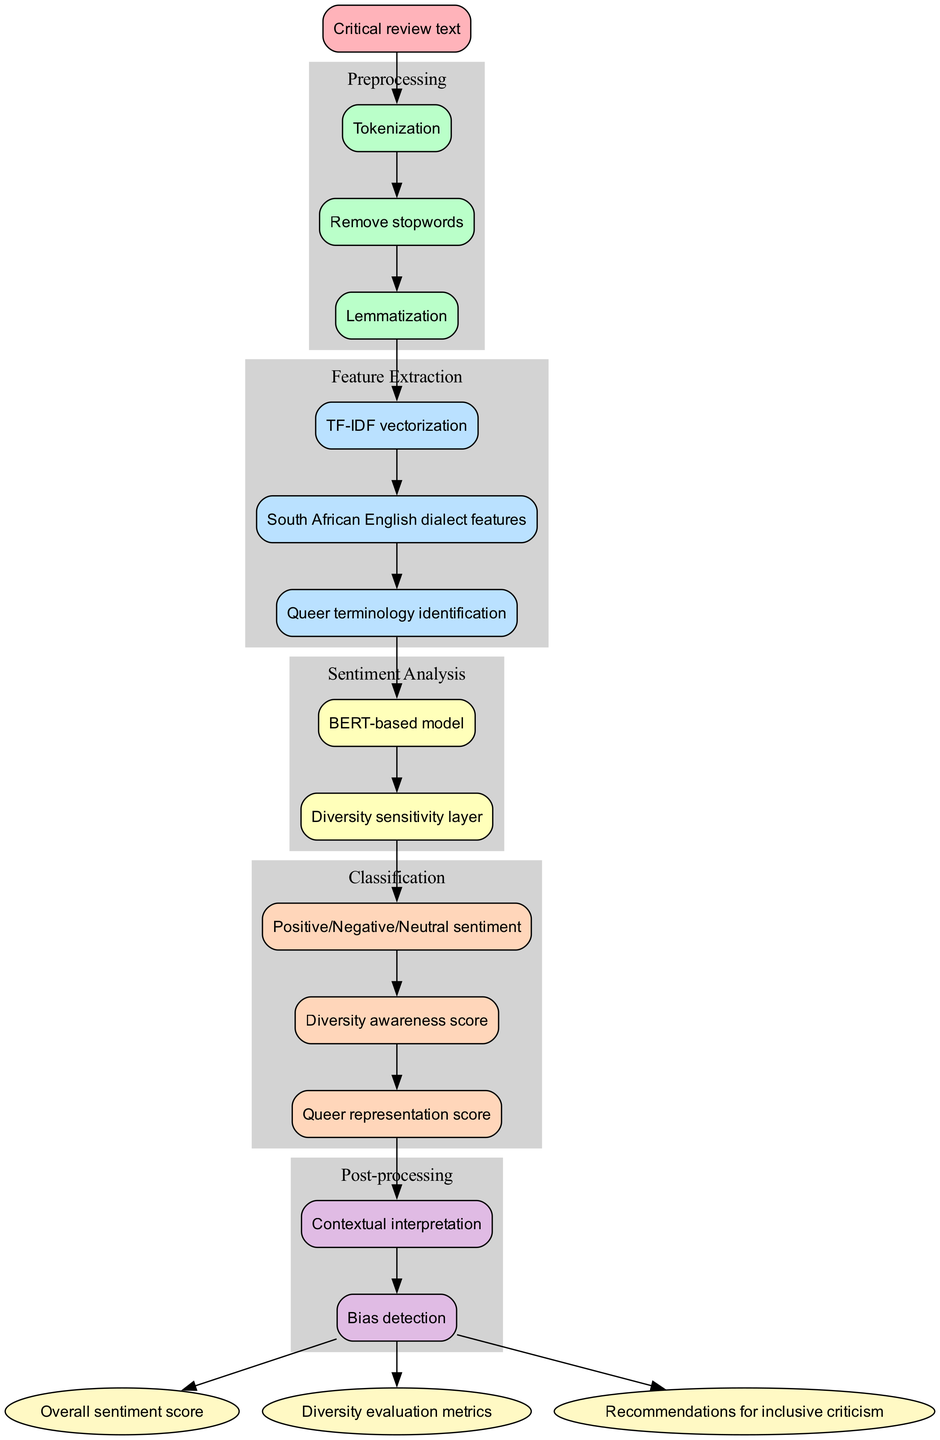What is the initial input of the flowchart? The flowchart starts with the initial input specified at the top, which is "Critical review text". This is the very first node of the diagram, clearly indicating the nature of the data being processed.
Answer: Critical review text How many preprocessing steps are there? By examining the preprocessing section of the diagram, we can count three distinct steps listed: "Tokenization", "Remove stopwords", and "Lemmatization". Thus, the total number is three.
Answer: 3 What is the first feature extraction method? Looking into the feature extraction part, the first method listed is "TF-IDF vectorization". This is the first node that occurs in this stage of the flowchart.
Answer: TF-IDF vectorization Which sentiment analysis model is employed in the diagram? The sentiment analysis section specifies a model type as "BERT-based model". This indicates the specific framework being utilized for the sentiment analysis task within the flowchart.
Answer: BERT-based model What comes after the post-processing step? The final outputs are listed after the post-processing section in the diagram. They include "Overall sentiment score", "Diversity evaluation metrics", and "Recommendations for inclusive criticism". Therefore, anything related to outputs follows post-processing.
Answer: Outputs What are the classification stages based on the sentiment analysis? The diagram outlines three classification stages: "Positive/Negative/Neutral sentiment", "Diversity awareness score", and "Queer representation score". These stages follow the sentiment analysis component.
Answer: Positive/Negative/Neutral sentiment, Diversity awareness score, Queer representation score How does the flow from feature extraction to sentiment analysis occur? The flow progresses from the last feature extraction method, identified as "Queer terminology identification", directly to the first sentiment analysis node, which is "BERT-based model". The arrow connecting these steps signifies that the features extracted are utilized in the subsequent sentiment analysis stage.
Answer: From Queer terminology identification to BERT-based model What is the purpose of the diversity sensitivity layer in sentiment analysis? The "Diversity sensitivity layer" is positioned as part of the sentiment analysis methods, suggesting its role is to account for diverse perspectives in the analysis, particularly focusing on inclusivity in literature. It acts as an added layer for analyzing the sentiments with a special focus on diversity aspects.
Answer: To account for diverse perspectives How many output metrics are produced after post-processing? The diagram indicates three distinctive outputs after the post-processing stage: "Overall sentiment score", "Diversity evaluation metrics", and "Recommendations for inclusive criticism". Thus, the total number of output metrics is three.
Answer: 3 